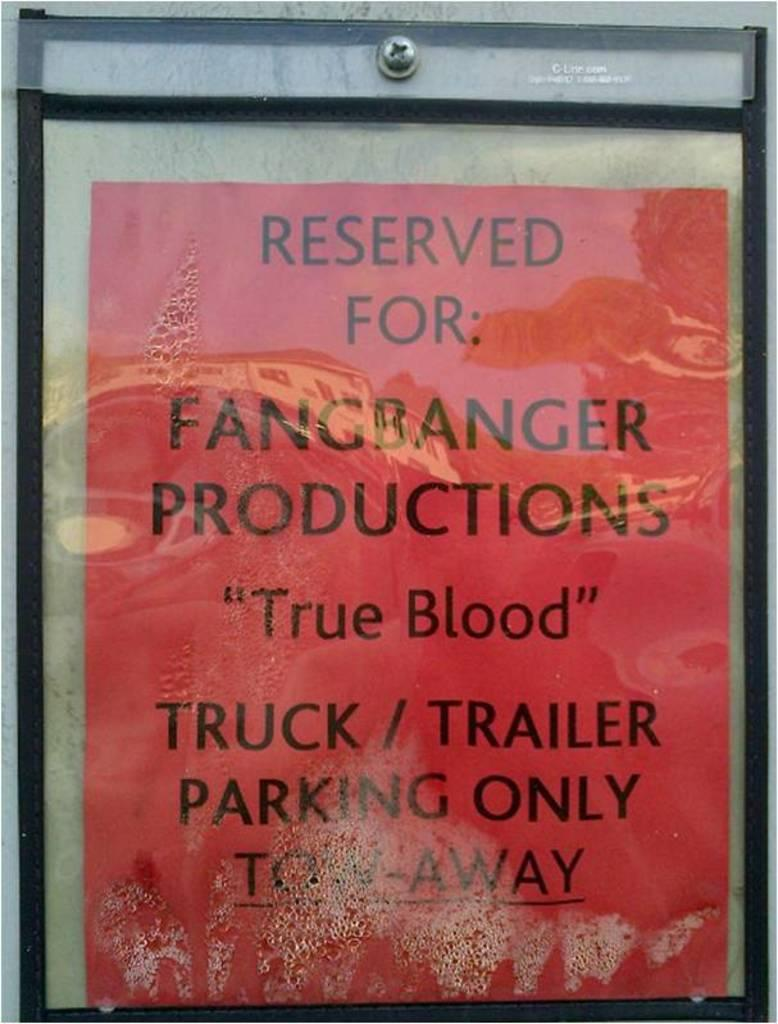<image>
Summarize the visual content of the image. A red signs says "reserved for fangranger productions. 